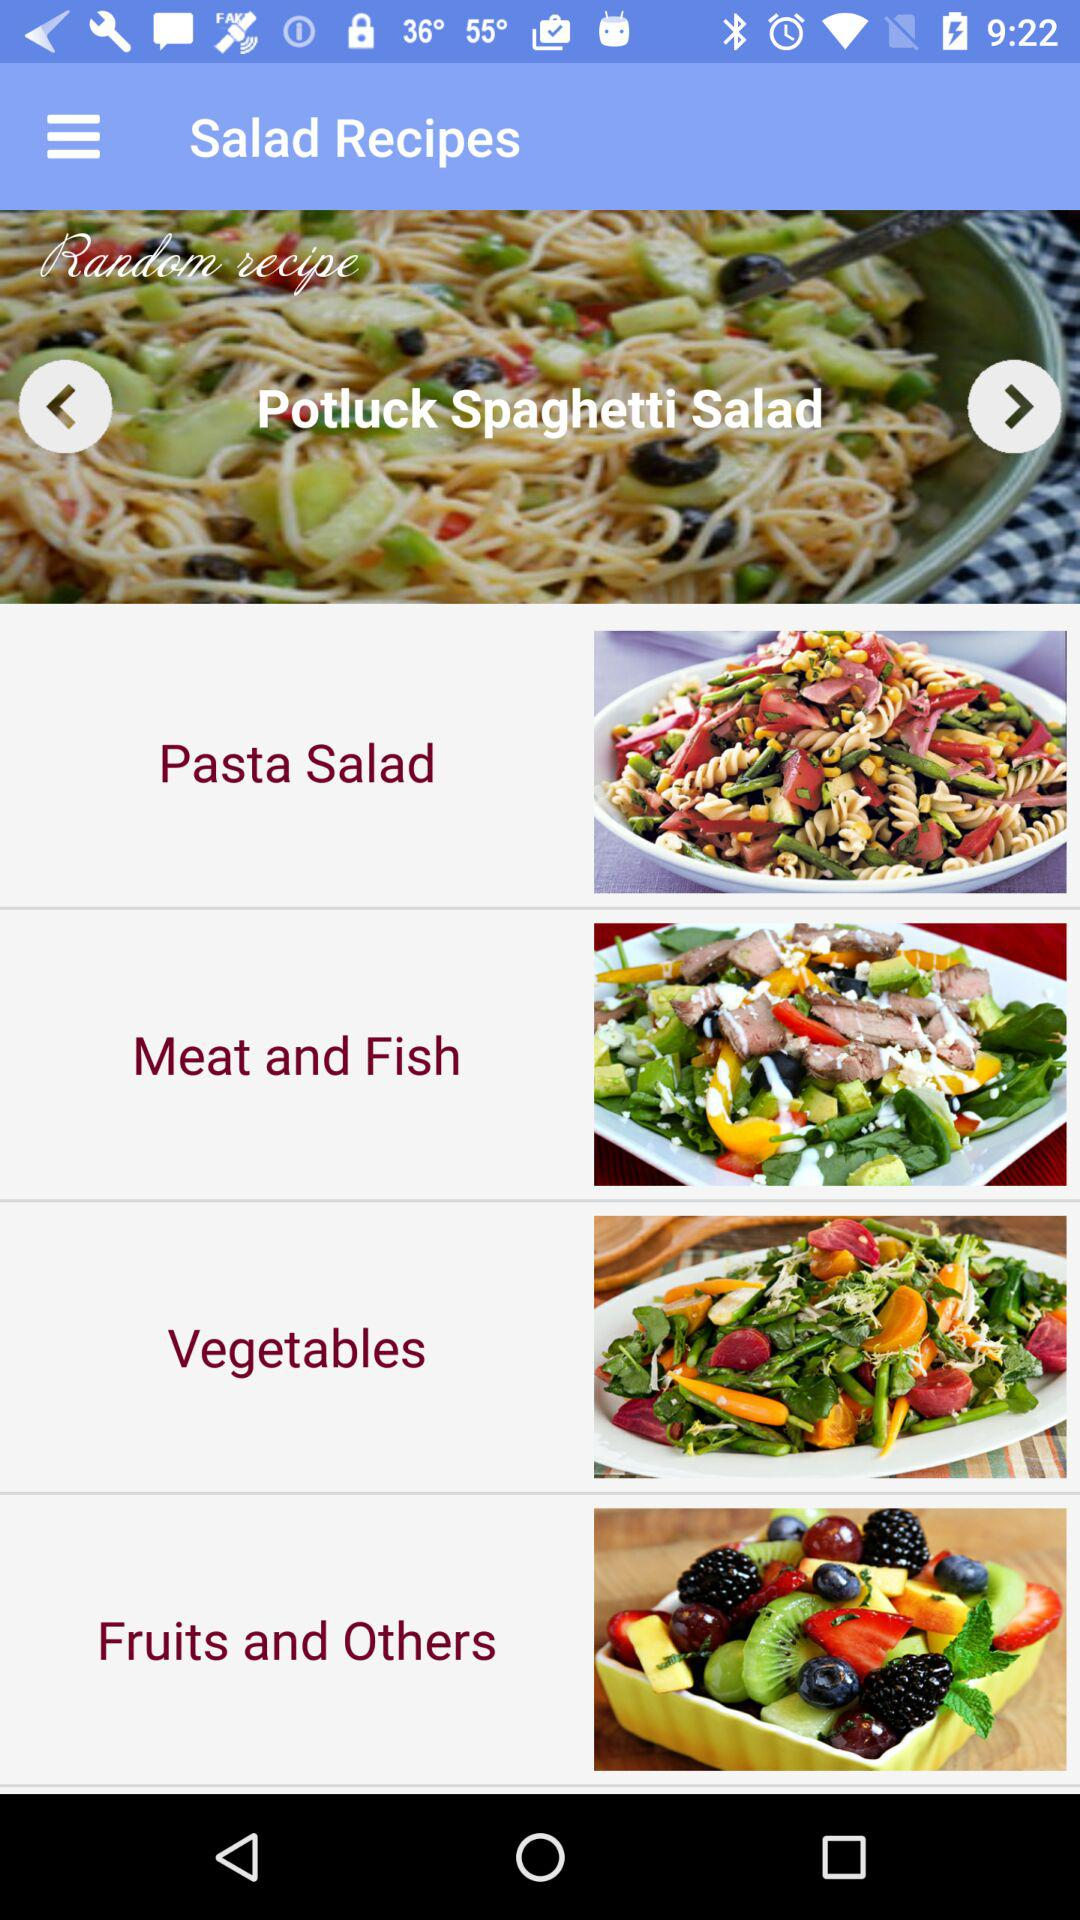What are the different available salad recipes? The different available salad recipes are "Potluck Spaghetti Salad", "Pasta Salad", "Meat and Fish", "Vegetables" and "Fruits and Others". 